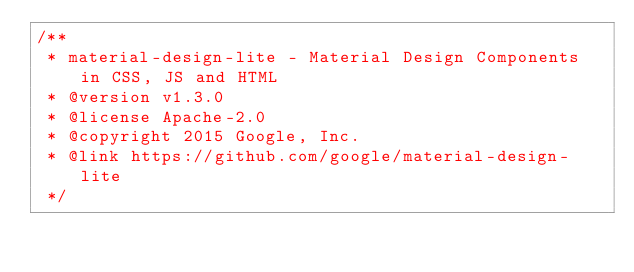<code> <loc_0><loc_0><loc_500><loc_500><_JavaScript_>/**
 * material-design-lite - Material Design Components in CSS, JS and HTML
 * @version v1.3.0
 * @license Apache-2.0
 * @copyright 2015 Google, Inc.
 * @link https://github.com/google/material-design-lite
 */</code> 